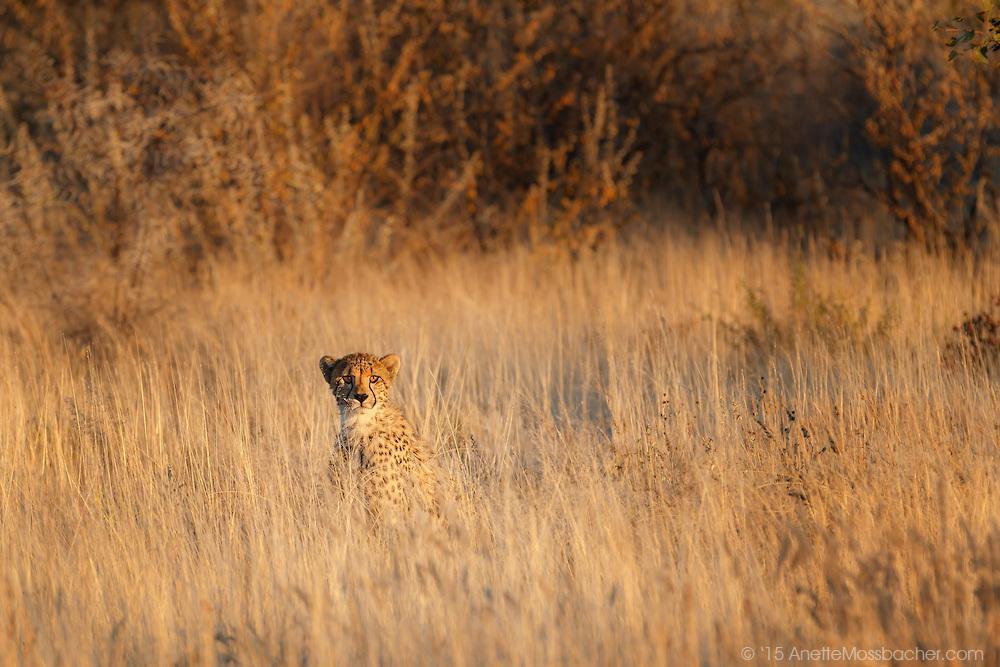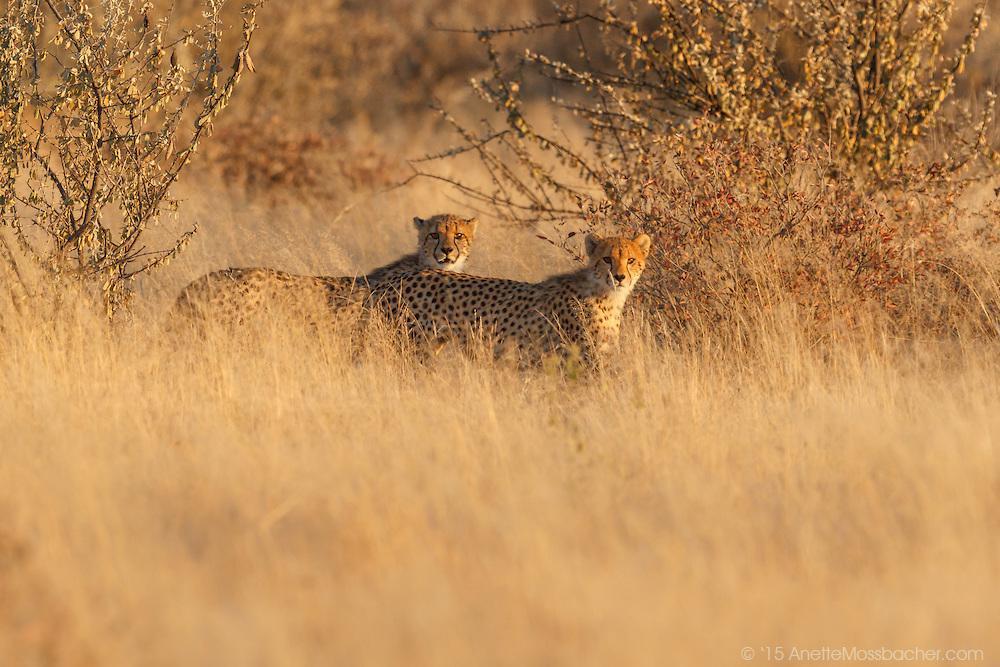The first image is the image on the left, the second image is the image on the right. Analyze the images presented: Is the assertion "There is a least one cheetah in each image peering out through the tall grass." valid? Answer yes or no. Yes. The first image is the image on the left, the second image is the image on the right. Considering the images on both sides, is "Two spotted leopards are standing next to each other." valid? Answer yes or no. Yes. 